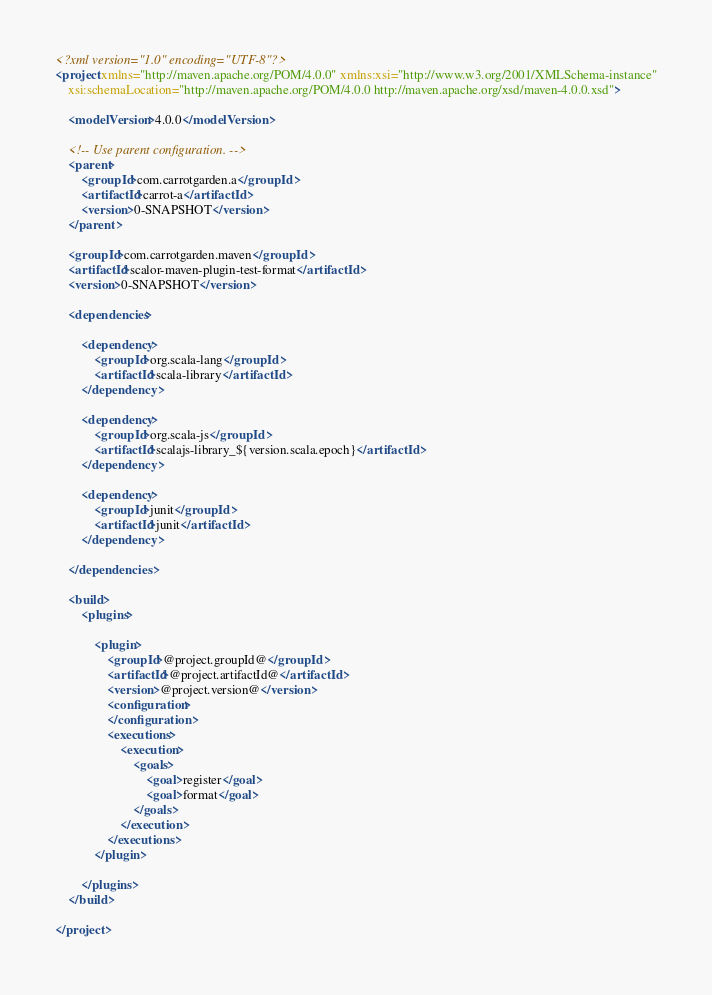<code> <loc_0><loc_0><loc_500><loc_500><_XML_><?xml version="1.0" encoding="UTF-8"?>
<project xmlns="http://maven.apache.org/POM/4.0.0" xmlns:xsi="http://www.w3.org/2001/XMLSchema-instance"
    xsi:schemaLocation="http://maven.apache.org/POM/4.0.0 http://maven.apache.org/xsd/maven-4.0.0.xsd">

    <modelVersion>4.0.0</modelVersion>

    <!-- Use parent configuration. -->
    <parent>
        <groupId>com.carrotgarden.a</groupId>
        <artifactId>carrot-a</artifactId>
        <version>0-SNAPSHOT</version>
    </parent>

    <groupId>com.carrotgarden.maven</groupId>
    <artifactId>scalor-maven-plugin-test-format</artifactId>
    <version>0-SNAPSHOT</version>

    <dependencies>

        <dependency>
            <groupId>org.scala-lang</groupId>
            <artifactId>scala-library</artifactId>
        </dependency>

        <dependency>
            <groupId>org.scala-js</groupId>
            <artifactId>scalajs-library_${version.scala.epoch}</artifactId>
        </dependency>

        <dependency>
            <groupId>junit</groupId>
            <artifactId>junit</artifactId>
        </dependency>

    </dependencies>

    <build>
        <plugins>

            <plugin>
                <groupId>@project.groupId@</groupId>
                <artifactId>@project.artifactId@</artifactId>
                <version>@project.version@</version>
                <configuration>
                </configuration>
                <executions>
                    <execution>
                        <goals>
                            <goal>register</goal>
                            <goal>format</goal>
                        </goals>
                    </execution>
                </executions>
            </plugin>

        </plugins>
    </build>

</project>
</code> 